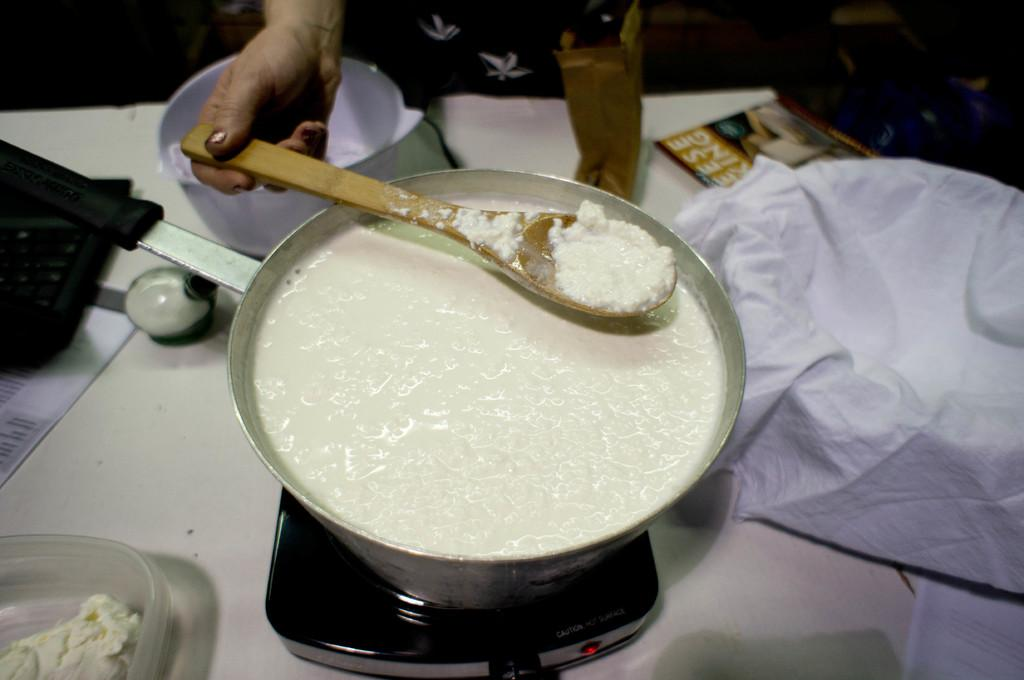<image>
Present a compact description of the photo's key features. A person stirs a white mixture with a wooden spoon as a magazine with "king" in the title sits next to them. 